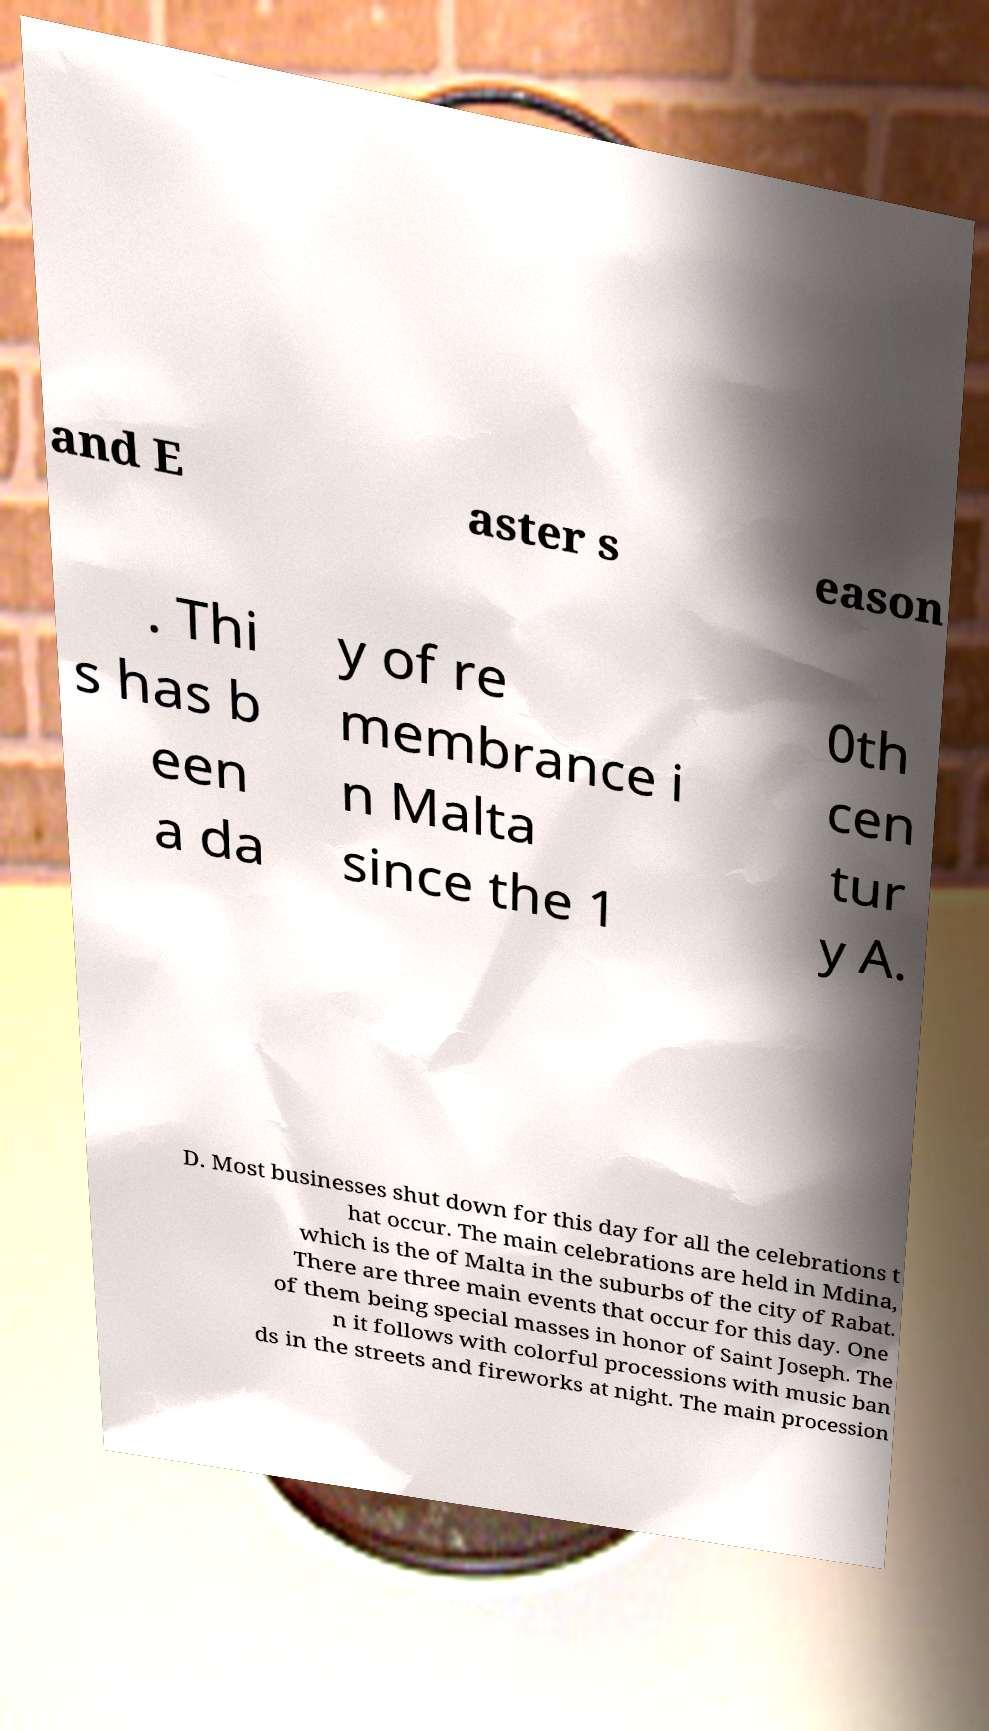There's text embedded in this image that I need extracted. Can you transcribe it verbatim? and E aster s eason . Thi s has b een a da y of re membrance i n Malta since the 1 0th cen tur y A. D. Most businesses shut down for this day for all the celebrations t hat occur. The main celebrations are held in Mdina, which is the of Malta in the suburbs of the city of Rabat. There are three main events that occur for this day. One of them being special masses in honor of Saint Joseph. The n it follows with colorful processions with music ban ds in the streets and fireworks at night. The main procession 